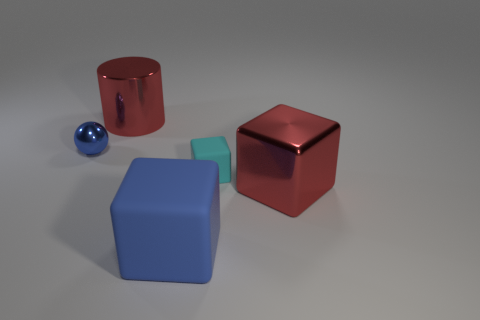Add 4 big yellow metallic balls. How many objects exist? 9 Subtract all balls. How many objects are left? 4 Add 4 cylinders. How many cylinders are left? 5 Add 4 tiny metallic objects. How many tiny metallic objects exist? 5 Subtract 0 cyan balls. How many objects are left? 5 Subtract all big red matte cylinders. Subtract all rubber cubes. How many objects are left? 3 